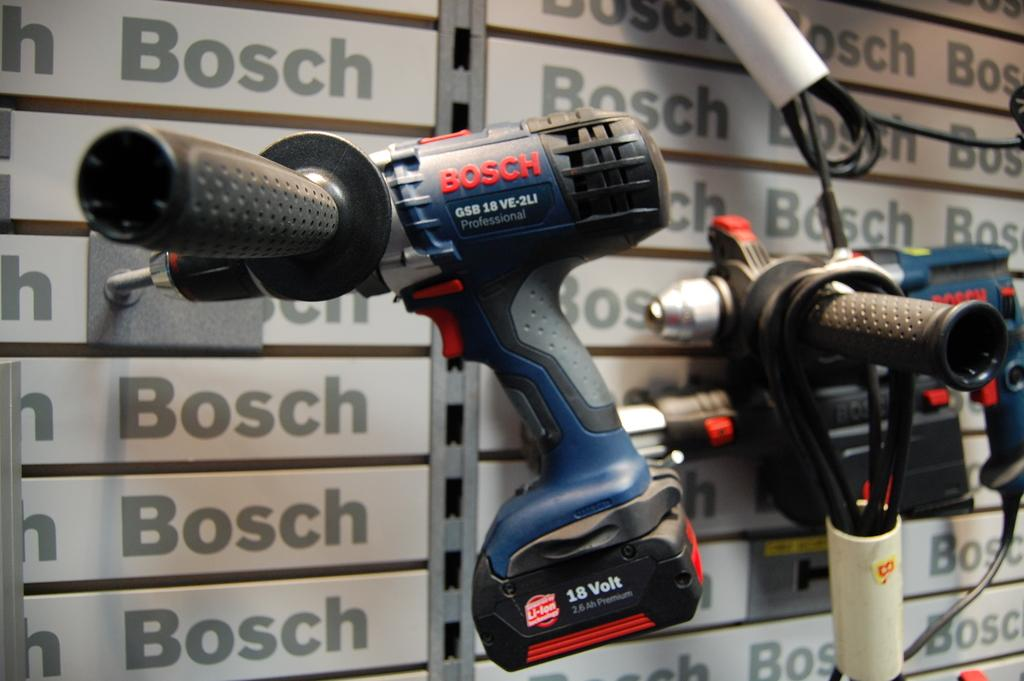What color are the equipment visible in the image? The equipment in the image is blue-colored. What else can be seen in the image besides the equipment? There are wires visible in the image. What is present in the background of the image? In the background of the image, something is written at many places. What songs can be heard playing in the background of the image? There is no audio or music present in the image, so it is not possible to determine what songs might be heard. 